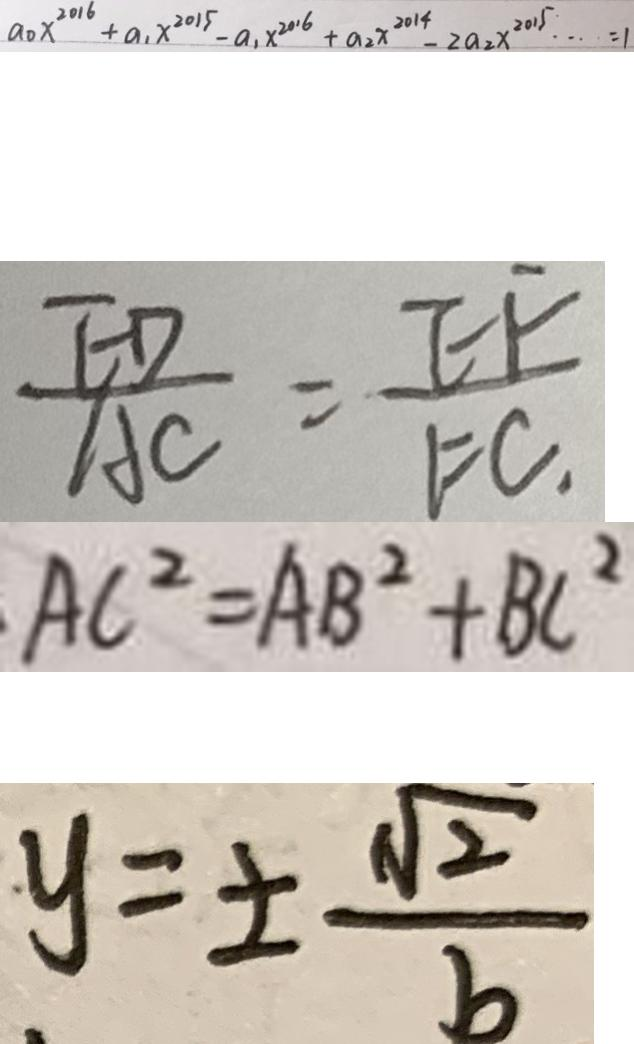Convert formula to latex. <formula><loc_0><loc_0><loc_500><loc_500>a _ { 0 } x ^ { 2 0 1 6 } + a _ { 1 } x ^ { 2 0 1 5 } - a _ { 1 } x ^ { 2 0 1 6 } + a _ { 2 } x ^ { 2 0 1 4 } - 2 a _ { 2 } x ^ { 2 0 1 5 } \cdots = 1 
 \frac { E D } { A C } = \frac { E F } { F C . } 
 A C ^ { 2 } = A B ^ { 2 } + B C ^ { 2 } 
 y = \pm \frac { \sqrt { 2 } } { b }</formula> 